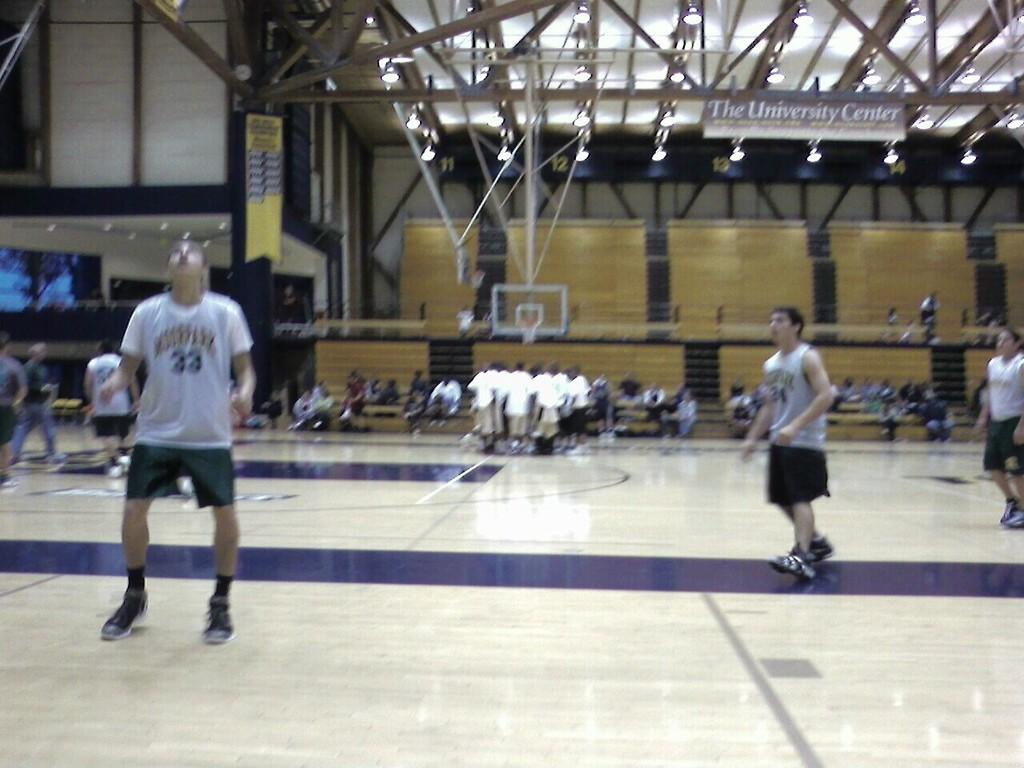What can be seen in the image? There are persons standing in the image. What are the persons wearing? The persons are wearing clothes. What is visible at the top of the image? There are lights at the top of the image. What type of glass can be seen on the slope in the image? There is no glass or slope present in the image. How many drawers are visible in the image? There are no drawers present in the image. 